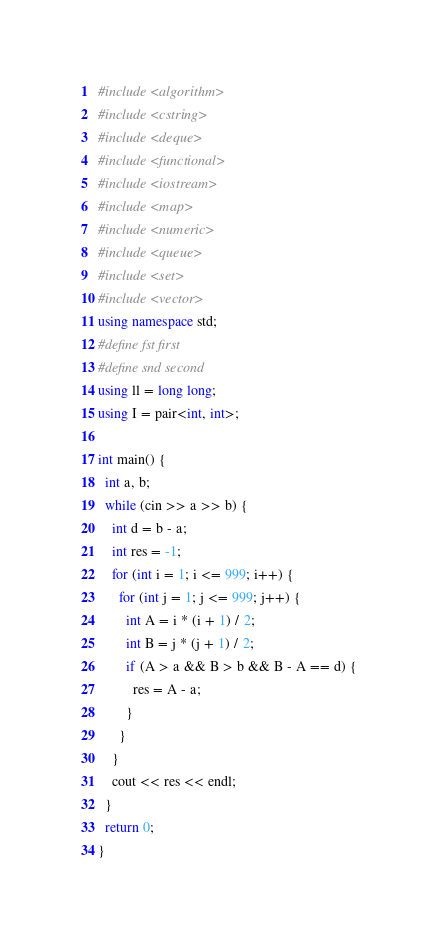Convert code to text. <code><loc_0><loc_0><loc_500><loc_500><_C++_>#include <algorithm>
#include <cstring>
#include <deque>
#include <functional>
#include <iostream>
#include <map>
#include <numeric>
#include <queue>
#include <set>
#include <vector>
using namespace std;
#define fst first
#define snd second
using ll = long long;
using I = pair<int, int>;

int main() {
  int a, b;
  while (cin >> a >> b) {
    int d = b - a;
    int res = -1;
    for (int i = 1; i <= 999; i++) {
      for (int j = 1; j <= 999; j++) {
        int A = i * (i + 1) / 2;
        int B = j * (j + 1) / 2;
        if (A > a && B > b && B - A == d) {
          res = A - a;
        }
      }
    }
    cout << res << endl;
  }
  return 0;
}
</code> 